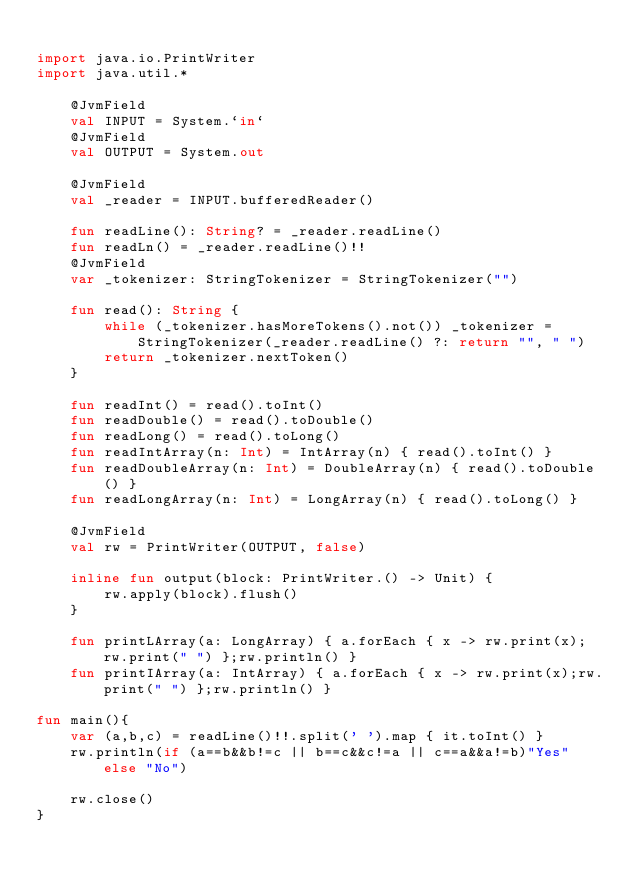<code> <loc_0><loc_0><loc_500><loc_500><_Kotlin_>
import java.io.PrintWriter
import java.util.*

    @JvmField
    val INPUT = System.`in`
    @JvmField
    val OUTPUT = System.out

    @JvmField
    val _reader = INPUT.bufferedReader()

    fun readLine(): String? = _reader.readLine()
    fun readLn() = _reader.readLine()!!
    @JvmField
    var _tokenizer: StringTokenizer = StringTokenizer("")

    fun read(): String {
        while (_tokenizer.hasMoreTokens().not()) _tokenizer = StringTokenizer(_reader.readLine() ?: return "", " ")
        return _tokenizer.nextToken()
    }

    fun readInt() = read().toInt()
    fun readDouble() = read().toDouble()
    fun readLong() = read().toLong()
    fun readIntArray(n: Int) = IntArray(n) { read().toInt() }
    fun readDoubleArray(n: Int) = DoubleArray(n) { read().toDouble() }
    fun readLongArray(n: Int) = LongArray(n) { read().toLong() }

    @JvmField
    val rw = PrintWriter(OUTPUT, false)

    inline fun output(block: PrintWriter.() -> Unit) {
        rw.apply(block).flush()
    }

    fun printLArray(a: LongArray) { a.forEach { x -> rw.print(x); rw.print(" ") };rw.println() }
    fun printIArray(a: IntArray) { a.forEach { x -> rw.print(x);rw.print(" ") };rw.println() }

fun main(){
    var (a,b,c) = readLine()!!.split(' ').map { it.toInt() }
    rw.println(if (a==b&&b!=c || b==c&&c!=a || c==a&&a!=b)"Yes" else "No")

    rw.close()
}</code> 